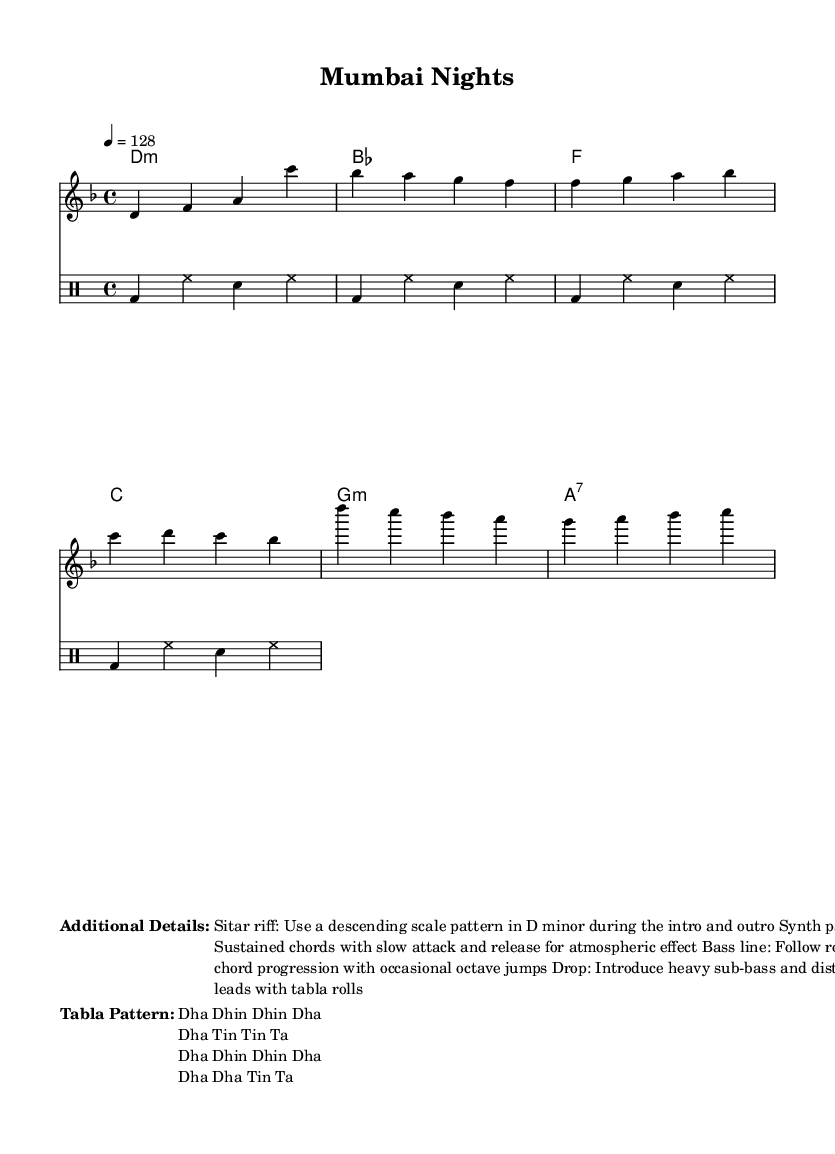What is the key signature of this music? The key signature is D minor, indicated by one flat (B-flat) on the staff.
Answer: D minor What is the time signature of the piece? The time signature is 4/4, which is indicated at the beginning of the score. This means there are four beats in each measure.
Answer: 4/4 What is the tempo marking for this piece? The tempo marking is 128 beats per minute, specified at the start of the score.
Answer: 128 What is the first chord of the song? The first chord is D minor, indicated as "d1:m" in the chord progression at the beginning of the harmonies section.
Answer: D minor How many measures does the verse section have? The verse section has two measures, as indicated by the grouping of notes before the pre-chorus starts.
Answer: 2 What rhythmic pattern is used for the tabla? The tabla pattern is identified as "Dha Dhin Dhin Dha" and other variations, which are integral to the music style presented.
Answer: Dha Dhin Dhin Dha What instrument primarily plays the melody in this score? The melody is primarily played by a voice part within the staff dedicated to the melody line.
Answer: Voice 